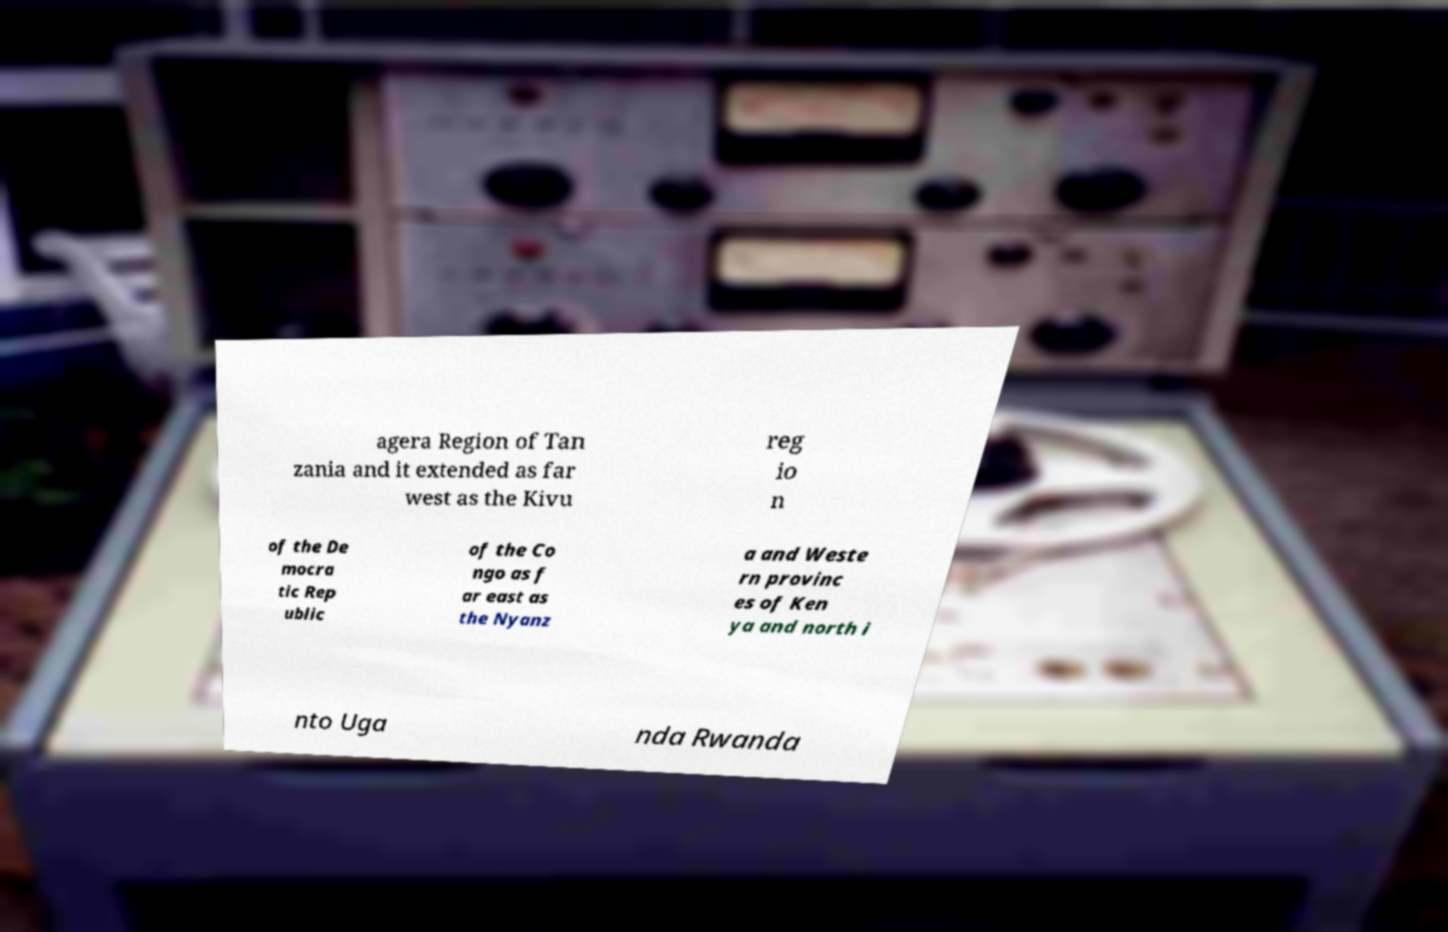What messages or text are displayed in this image? I need them in a readable, typed format. agera Region of Tan zania and it extended as far west as the Kivu reg io n of the De mocra tic Rep ublic of the Co ngo as f ar east as the Nyanz a and Weste rn provinc es of Ken ya and north i nto Uga nda Rwanda 